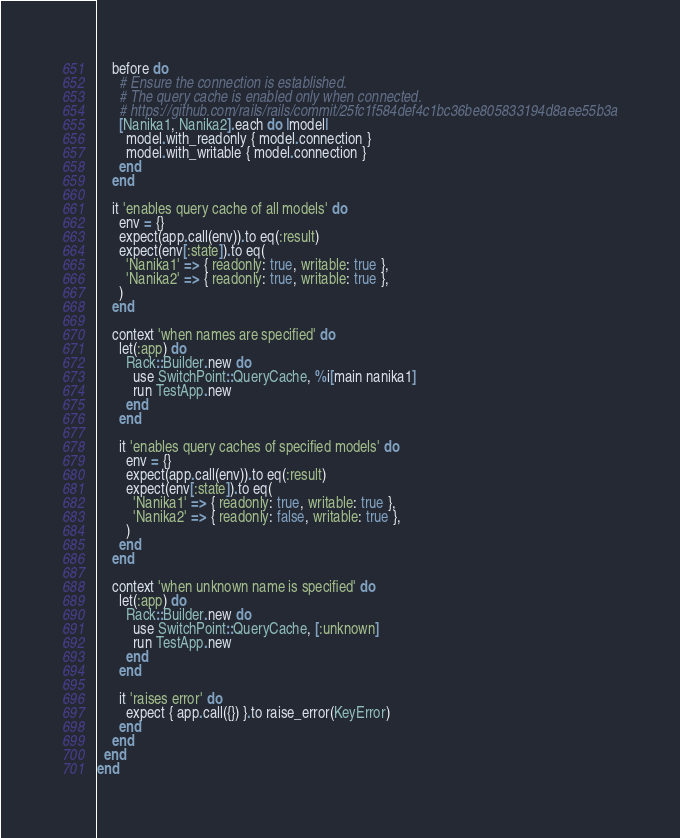Convert code to text. <code><loc_0><loc_0><loc_500><loc_500><_Ruby_>    before do
      # Ensure the connection is established.
      # The query cache is enabled only when connected.
      # https://github.com/rails/rails/commit/25fc1f584def4c1bc36be805833194d8aee55b3a
      [Nanika1, Nanika2].each do |model|
        model.with_readonly { model.connection }
        model.with_writable { model.connection }
      end
    end

    it 'enables query cache of all models' do
      env = {}
      expect(app.call(env)).to eq(:result)
      expect(env[:state]).to eq(
        'Nanika1' => { readonly: true, writable: true },
        'Nanika2' => { readonly: true, writable: true },
      )
    end

    context 'when names are specified' do
      let(:app) do
        Rack::Builder.new do
          use SwitchPoint::QueryCache, %i[main nanika1]
          run TestApp.new
        end
      end

      it 'enables query caches of specified models' do
        env = {}
        expect(app.call(env)).to eq(:result)
        expect(env[:state]).to eq(
          'Nanika1' => { readonly: true, writable: true },
          'Nanika2' => { readonly: false, writable: true },
        )
      end
    end

    context 'when unknown name is specified' do
      let(:app) do
        Rack::Builder.new do
          use SwitchPoint::QueryCache, [:unknown]
          run TestApp.new
        end
      end

      it 'raises error' do
        expect { app.call({}) }.to raise_error(KeyError)
      end
    end
  end
end
</code> 